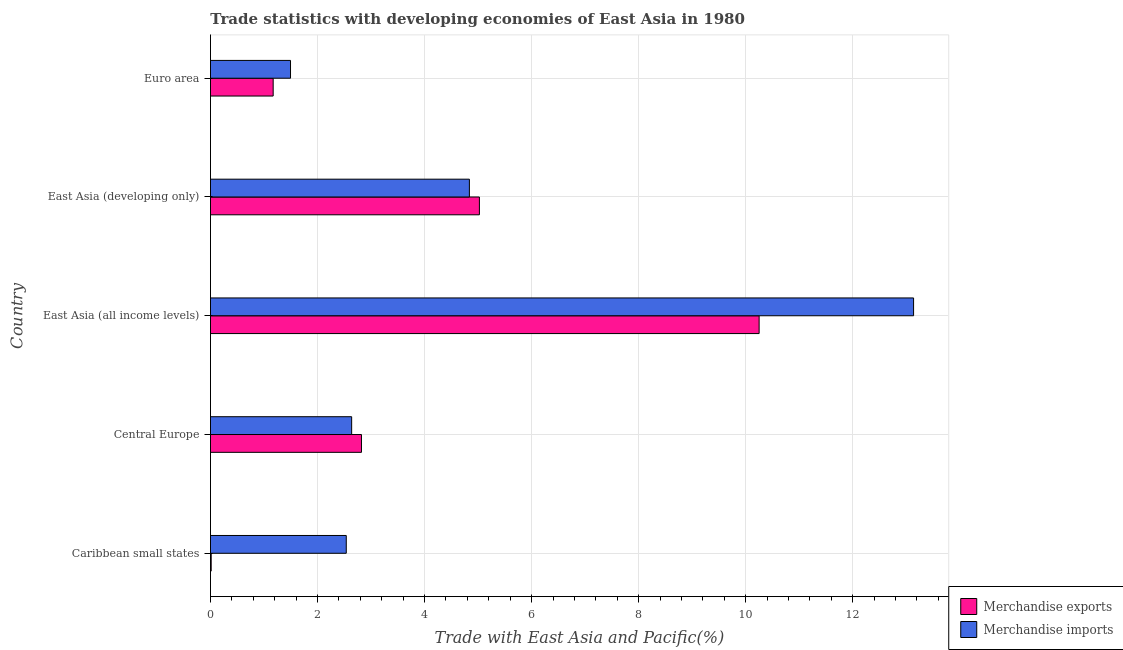How many different coloured bars are there?
Provide a succinct answer. 2. How many groups of bars are there?
Your answer should be very brief. 5. Are the number of bars per tick equal to the number of legend labels?
Provide a succinct answer. Yes. Are the number of bars on each tick of the Y-axis equal?
Provide a succinct answer. Yes. How many bars are there on the 5th tick from the top?
Keep it short and to the point. 2. What is the label of the 4th group of bars from the top?
Give a very brief answer. Central Europe. What is the merchandise exports in East Asia (all income levels)?
Provide a succinct answer. 10.25. Across all countries, what is the maximum merchandise imports?
Keep it short and to the point. 13.14. Across all countries, what is the minimum merchandise imports?
Offer a terse response. 1.5. In which country was the merchandise exports maximum?
Make the answer very short. East Asia (all income levels). In which country was the merchandise exports minimum?
Provide a succinct answer. Caribbean small states. What is the total merchandise imports in the graph?
Your answer should be very brief. 24.65. What is the difference between the merchandise exports in East Asia (developing only) and that in Euro area?
Ensure brevity in your answer.  3.85. What is the difference between the merchandise exports in Euro area and the merchandise imports in East Asia (developing only)?
Offer a very short reply. -3.67. What is the average merchandise exports per country?
Give a very brief answer. 3.86. What is the difference between the merchandise exports and merchandise imports in East Asia (developing only)?
Offer a very short reply. 0.19. In how many countries, is the merchandise imports greater than 5.6 %?
Offer a terse response. 1. What is the ratio of the merchandise exports in Central Europe to that in East Asia (developing only)?
Give a very brief answer. 0.56. Is the merchandise imports in East Asia (all income levels) less than that in Euro area?
Make the answer very short. No. Is the difference between the merchandise exports in East Asia (all income levels) and East Asia (developing only) greater than the difference between the merchandise imports in East Asia (all income levels) and East Asia (developing only)?
Keep it short and to the point. No. What is the difference between the highest and the second highest merchandise exports?
Provide a short and direct response. 5.23. What is the difference between the highest and the lowest merchandise imports?
Your response must be concise. 11.64. Is the sum of the merchandise exports in East Asia (all income levels) and Euro area greater than the maximum merchandise imports across all countries?
Offer a very short reply. No. What does the 2nd bar from the bottom in Euro area represents?
Offer a terse response. Merchandise imports. Are all the bars in the graph horizontal?
Provide a short and direct response. Yes. What is the difference between two consecutive major ticks on the X-axis?
Provide a short and direct response. 2. Does the graph contain any zero values?
Offer a terse response. No. Does the graph contain grids?
Your response must be concise. Yes. How are the legend labels stacked?
Your response must be concise. Vertical. What is the title of the graph?
Offer a very short reply. Trade statistics with developing economies of East Asia in 1980. Does "Young" appear as one of the legend labels in the graph?
Provide a short and direct response. No. What is the label or title of the X-axis?
Offer a very short reply. Trade with East Asia and Pacific(%). What is the Trade with East Asia and Pacific(%) of Merchandise exports in Caribbean small states?
Offer a very short reply. 0.01. What is the Trade with East Asia and Pacific(%) of Merchandise imports in Caribbean small states?
Make the answer very short. 2.54. What is the Trade with East Asia and Pacific(%) in Merchandise exports in Central Europe?
Provide a succinct answer. 2.82. What is the Trade with East Asia and Pacific(%) of Merchandise imports in Central Europe?
Offer a very short reply. 2.64. What is the Trade with East Asia and Pacific(%) in Merchandise exports in East Asia (all income levels)?
Offer a terse response. 10.25. What is the Trade with East Asia and Pacific(%) in Merchandise imports in East Asia (all income levels)?
Provide a short and direct response. 13.14. What is the Trade with East Asia and Pacific(%) of Merchandise exports in East Asia (developing only)?
Provide a short and direct response. 5.02. What is the Trade with East Asia and Pacific(%) in Merchandise imports in East Asia (developing only)?
Make the answer very short. 4.84. What is the Trade with East Asia and Pacific(%) in Merchandise exports in Euro area?
Offer a terse response. 1.17. What is the Trade with East Asia and Pacific(%) of Merchandise imports in Euro area?
Ensure brevity in your answer.  1.5. Across all countries, what is the maximum Trade with East Asia and Pacific(%) of Merchandise exports?
Give a very brief answer. 10.25. Across all countries, what is the maximum Trade with East Asia and Pacific(%) in Merchandise imports?
Ensure brevity in your answer.  13.14. Across all countries, what is the minimum Trade with East Asia and Pacific(%) of Merchandise exports?
Make the answer very short. 0.01. Across all countries, what is the minimum Trade with East Asia and Pacific(%) of Merchandise imports?
Provide a short and direct response. 1.5. What is the total Trade with East Asia and Pacific(%) in Merchandise exports in the graph?
Your answer should be compact. 19.28. What is the total Trade with East Asia and Pacific(%) of Merchandise imports in the graph?
Your answer should be very brief. 24.65. What is the difference between the Trade with East Asia and Pacific(%) of Merchandise exports in Caribbean small states and that in Central Europe?
Your answer should be compact. -2.81. What is the difference between the Trade with East Asia and Pacific(%) in Merchandise imports in Caribbean small states and that in Central Europe?
Offer a terse response. -0.1. What is the difference between the Trade with East Asia and Pacific(%) of Merchandise exports in Caribbean small states and that in East Asia (all income levels)?
Ensure brevity in your answer.  -10.24. What is the difference between the Trade with East Asia and Pacific(%) in Merchandise imports in Caribbean small states and that in East Asia (all income levels)?
Make the answer very short. -10.6. What is the difference between the Trade with East Asia and Pacific(%) of Merchandise exports in Caribbean small states and that in East Asia (developing only)?
Give a very brief answer. -5.01. What is the difference between the Trade with East Asia and Pacific(%) of Merchandise imports in Caribbean small states and that in East Asia (developing only)?
Give a very brief answer. -2.3. What is the difference between the Trade with East Asia and Pacific(%) in Merchandise exports in Caribbean small states and that in Euro area?
Offer a terse response. -1.16. What is the difference between the Trade with East Asia and Pacific(%) of Merchandise imports in Caribbean small states and that in Euro area?
Make the answer very short. 1.04. What is the difference between the Trade with East Asia and Pacific(%) in Merchandise exports in Central Europe and that in East Asia (all income levels)?
Provide a short and direct response. -7.43. What is the difference between the Trade with East Asia and Pacific(%) in Merchandise imports in Central Europe and that in East Asia (all income levels)?
Your answer should be compact. -10.5. What is the difference between the Trade with East Asia and Pacific(%) of Merchandise exports in Central Europe and that in East Asia (developing only)?
Your answer should be very brief. -2.2. What is the difference between the Trade with East Asia and Pacific(%) in Merchandise imports in Central Europe and that in East Asia (developing only)?
Give a very brief answer. -2.2. What is the difference between the Trade with East Asia and Pacific(%) of Merchandise exports in Central Europe and that in Euro area?
Offer a terse response. 1.65. What is the difference between the Trade with East Asia and Pacific(%) in Merchandise imports in Central Europe and that in Euro area?
Your response must be concise. 1.14. What is the difference between the Trade with East Asia and Pacific(%) of Merchandise exports in East Asia (all income levels) and that in East Asia (developing only)?
Ensure brevity in your answer.  5.23. What is the difference between the Trade with East Asia and Pacific(%) in Merchandise imports in East Asia (all income levels) and that in East Asia (developing only)?
Give a very brief answer. 8.3. What is the difference between the Trade with East Asia and Pacific(%) of Merchandise exports in East Asia (all income levels) and that in Euro area?
Offer a terse response. 9.08. What is the difference between the Trade with East Asia and Pacific(%) in Merchandise imports in East Asia (all income levels) and that in Euro area?
Provide a succinct answer. 11.64. What is the difference between the Trade with East Asia and Pacific(%) of Merchandise exports in East Asia (developing only) and that in Euro area?
Give a very brief answer. 3.85. What is the difference between the Trade with East Asia and Pacific(%) of Merchandise imports in East Asia (developing only) and that in Euro area?
Provide a short and direct response. 3.34. What is the difference between the Trade with East Asia and Pacific(%) in Merchandise exports in Caribbean small states and the Trade with East Asia and Pacific(%) in Merchandise imports in Central Europe?
Provide a short and direct response. -2.62. What is the difference between the Trade with East Asia and Pacific(%) of Merchandise exports in Caribbean small states and the Trade with East Asia and Pacific(%) of Merchandise imports in East Asia (all income levels)?
Make the answer very short. -13.12. What is the difference between the Trade with East Asia and Pacific(%) of Merchandise exports in Caribbean small states and the Trade with East Asia and Pacific(%) of Merchandise imports in East Asia (developing only)?
Ensure brevity in your answer.  -4.82. What is the difference between the Trade with East Asia and Pacific(%) of Merchandise exports in Caribbean small states and the Trade with East Asia and Pacific(%) of Merchandise imports in Euro area?
Ensure brevity in your answer.  -1.48. What is the difference between the Trade with East Asia and Pacific(%) in Merchandise exports in Central Europe and the Trade with East Asia and Pacific(%) in Merchandise imports in East Asia (all income levels)?
Your answer should be compact. -10.32. What is the difference between the Trade with East Asia and Pacific(%) in Merchandise exports in Central Europe and the Trade with East Asia and Pacific(%) in Merchandise imports in East Asia (developing only)?
Your answer should be compact. -2.02. What is the difference between the Trade with East Asia and Pacific(%) of Merchandise exports in Central Europe and the Trade with East Asia and Pacific(%) of Merchandise imports in Euro area?
Offer a terse response. 1.33. What is the difference between the Trade with East Asia and Pacific(%) in Merchandise exports in East Asia (all income levels) and the Trade with East Asia and Pacific(%) in Merchandise imports in East Asia (developing only)?
Offer a very short reply. 5.41. What is the difference between the Trade with East Asia and Pacific(%) of Merchandise exports in East Asia (all income levels) and the Trade with East Asia and Pacific(%) of Merchandise imports in Euro area?
Keep it short and to the point. 8.76. What is the difference between the Trade with East Asia and Pacific(%) of Merchandise exports in East Asia (developing only) and the Trade with East Asia and Pacific(%) of Merchandise imports in Euro area?
Make the answer very short. 3.53. What is the average Trade with East Asia and Pacific(%) of Merchandise exports per country?
Your answer should be compact. 3.86. What is the average Trade with East Asia and Pacific(%) of Merchandise imports per country?
Keep it short and to the point. 4.93. What is the difference between the Trade with East Asia and Pacific(%) in Merchandise exports and Trade with East Asia and Pacific(%) in Merchandise imports in Caribbean small states?
Provide a short and direct response. -2.52. What is the difference between the Trade with East Asia and Pacific(%) in Merchandise exports and Trade with East Asia and Pacific(%) in Merchandise imports in Central Europe?
Your answer should be compact. 0.18. What is the difference between the Trade with East Asia and Pacific(%) of Merchandise exports and Trade with East Asia and Pacific(%) of Merchandise imports in East Asia (all income levels)?
Provide a succinct answer. -2.89. What is the difference between the Trade with East Asia and Pacific(%) of Merchandise exports and Trade with East Asia and Pacific(%) of Merchandise imports in East Asia (developing only)?
Provide a short and direct response. 0.19. What is the difference between the Trade with East Asia and Pacific(%) in Merchandise exports and Trade with East Asia and Pacific(%) in Merchandise imports in Euro area?
Provide a short and direct response. -0.32. What is the ratio of the Trade with East Asia and Pacific(%) in Merchandise exports in Caribbean small states to that in Central Europe?
Ensure brevity in your answer.  0. What is the ratio of the Trade with East Asia and Pacific(%) in Merchandise imports in Caribbean small states to that in Central Europe?
Make the answer very short. 0.96. What is the ratio of the Trade with East Asia and Pacific(%) in Merchandise exports in Caribbean small states to that in East Asia (all income levels)?
Provide a succinct answer. 0. What is the ratio of the Trade with East Asia and Pacific(%) of Merchandise imports in Caribbean small states to that in East Asia (all income levels)?
Your answer should be very brief. 0.19. What is the ratio of the Trade with East Asia and Pacific(%) of Merchandise exports in Caribbean small states to that in East Asia (developing only)?
Offer a very short reply. 0. What is the ratio of the Trade with East Asia and Pacific(%) in Merchandise imports in Caribbean small states to that in East Asia (developing only)?
Offer a terse response. 0.52. What is the ratio of the Trade with East Asia and Pacific(%) of Merchandise exports in Caribbean small states to that in Euro area?
Your answer should be very brief. 0.01. What is the ratio of the Trade with East Asia and Pacific(%) in Merchandise imports in Caribbean small states to that in Euro area?
Provide a short and direct response. 1.7. What is the ratio of the Trade with East Asia and Pacific(%) in Merchandise exports in Central Europe to that in East Asia (all income levels)?
Provide a short and direct response. 0.28. What is the ratio of the Trade with East Asia and Pacific(%) in Merchandise imports in Central Europe to that in East Asia (all income levels)?
Offer a terse response. 0.2. What is the ratio of the Trade with East Asia and Pacific(%) in Merchandise exports in Central Europe to that in East Asia (developing only)?
Make the answer very short. 0.56. What is the ratio of the Trade with East Asia and Pacific(%) of Merchandise imports in Central Europe to that in East Asia (developing only)?
Make the answer very short. 0.55. What is the ratio of the Trade with East Asia and Pacific(%) of Merchandise exports in Central Europe to that in Euro area?
Provide a succinct answer. 2.41. What is the ratio of the Trade with East Asia and Pacific(%) of Merchandise imports in Central Europe to that in Euro area?
Offer a terse response. 1.76. What is the ratio of the Trade with East Asia and Pacific(%) of Merchandise exports in East Asia (all income levels) to that in East Asia (developing only)?
Your answer should be compact. 2.04. What is the ratio of the Trade with East Asia and Pacific(%) in Merchandise imports in East Asia (all income levels) to that in East Asia (developing only)?
Your response must be concise. 2.72. What is the ratio of the Trade with East Asia and Pacific(%) of Merchandise exports in East Asia (all income levels) to that in Euro area?
Your answer should be very brief. 8.75. What is the ratio of the Trade with East Asia and Pacific(%) in Merchandise imports in East Asia (all income levels) to that in Euro area?
Keep it short and to the point. 8.78. What is the ratio of the Trade with East Asia and Pacific(%) in Merchandise exports in East Asia (developing only) to that in Euro area?
Your answer should be very brief. 4.29. What is the ratio of the Trade with East Asia and Pacific(%) of Merchandise imports in East Asia (developing only) to that in Euro area?
Provide a short and direct response. 3.23. What is the difference between the highest and the second highest Trade with East Asia and Pacific(%) in Merchandise exports?
Your response must be concise. 5.23. What is the difference between the highest and the second highest Trade with East Asia and Pacific(%) of Merchandise imports?
Your answer should be compact. 8.3. What is the difference between the highest and the lowest Trade with East Asia and Pacific(%) in Merchandise exports?
Your answer should be very brief. 10.24. What is the difference between the highest and the lowest Trade with East Asia and Pacific(%) in Merchandise imports?
Provide a short and direct response. 11.64. 